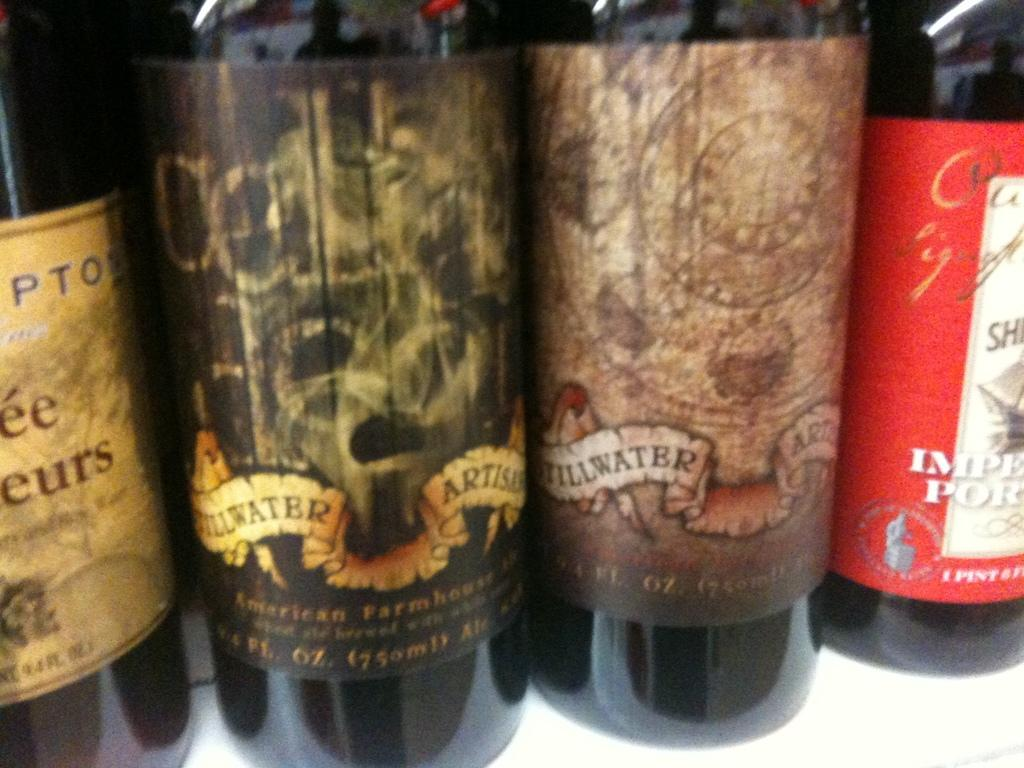What objects are present in the image? There are bottles in the image. Can you describe the bottles in the image? Unfortunately, the provided facts do not include any details about the bottles. Are there any other objects or people visible in the image? The given facts do not mention any other objects or people in the image. How many volleyballs are visible in the image? There are no volleyballs present in the image; it only features bottles. What finger is pointing at the calendar in the image? There is no calendar or finger present in the image, as it only contains bottles. 